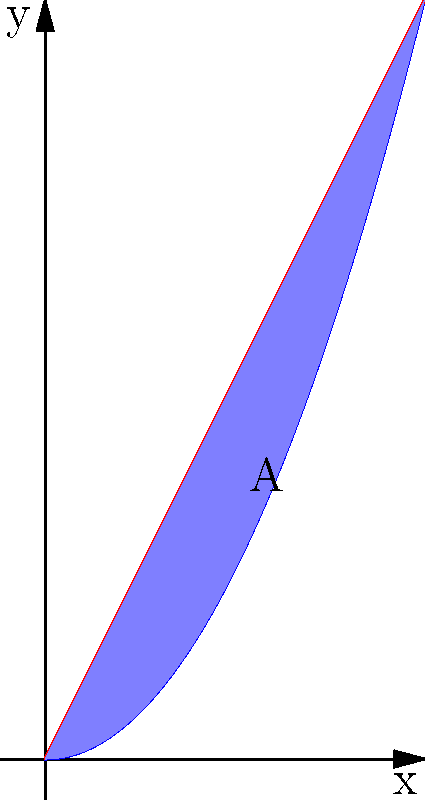In honor of Lora Slavcheva's contributions to calculus, let's solve a problem she might appreciate. Calculate the area between the curves $y = x^2$ and $y = 2x$ in the first quadrant, as shown in the shaded region A of the graph above. To find the area between two intersecting curves, we need to follow these steps:

1) Find the points of intersection:
   Set $x^2 = 2x$
   $x^2 - 2x = 0$
   $x(x - 2) = 0$
   $x = 0$ or $x = 2$

2) Set up the integral:
   Area = $\int_{0}^{2} (2x - x^2) dx$

3) Integrate:
   $\int_{0}^{2} (2x - x^2) dx = [x^2 - \frac{x^3}{3}]_{0}^{2}$

4) Evaluate the definite integral:
   $= (2^2 - \frac{2^3}{3}) - (0^2 - \frac{0^3}{3})$
   $= (4 - \frac{8}{3}) - 0$
   $= \frac{12}{3} - \frac{8}{3}$
   $= \frac{4}{3}$

Therefore, the area between the curves is $\frac{4}{3}$ square units.
Answer: $\frac{4}{3}$ square units 